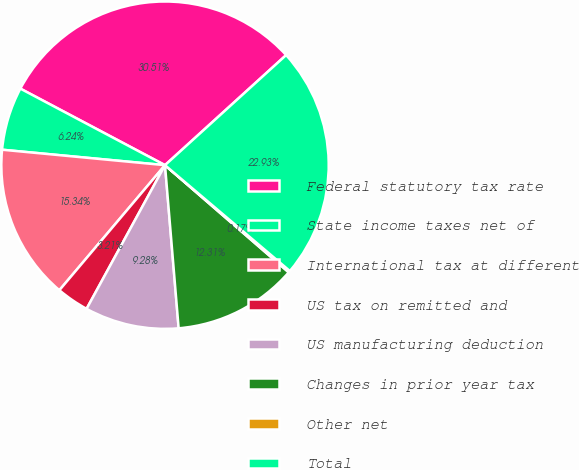Convert chart to OTSL. <chart><loc_0><loc_0><loc_500><loc_500><pie_chart><fcel>Federal statutory tax rate<fcel>State income taxes net of<fcel>International tax at different<fcel>US tax on remitted and<fcel>US manufacturing deduction<fcel>Changes in prior year tax<fcel>Other net<fcel>Total<nl><fcel>30.51%<fcel>6.24%<fcel>15.34%<fcel>3.21%<fcel>9.28%<fcel>12.31%<fcel>0.17%<fcel>22.93%<nl></chart> 